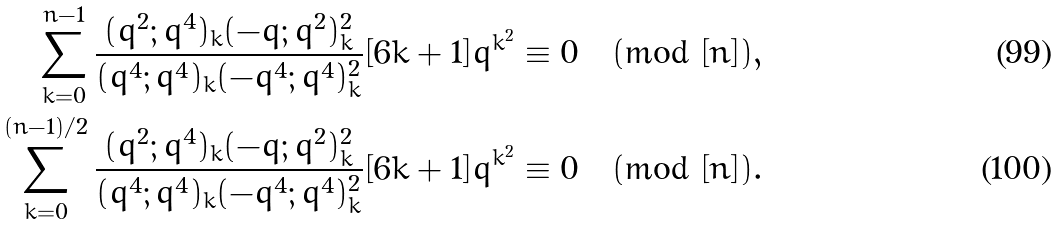<formula> <loc_0><loc_0><loc_500><loc_500>\sum _ { k = 0 } ^ { n - 1 } \frac { ( q ^ { 2 } ; q ^ { 4 } ) _ { k } ( - q ; q ^ { 2 } ) _ { k } ^ { 2 } } { ( q ^ { 4 } ; q ^ { 4 } ) _ { k } ( - q ^ { 4 } ; q ^ { 4 } ) _ { k } ^ { 2 } } [ 6 k + 1 ] q ^ { k ^ { 2 } } & \equiv 0 \pmod { [ n ] } , \\ \sum _ { k = 0 } ^ { ( n - 1 ) / 2 } \frac { ( q ^ { 2 } ; q ^ { 4 } ) _ { k } ( - q ; q ^ { 2 } ) _ { k } ^ { 2 } } { ( q ^ { 4 } ; q ^ { 4 } ) _ { k } ( - q ^ { 4 } ; q ^ { 4 } ) _ { k } ^ { 2 } } [ 6 k + 1 ] q ^ { k ^ { 2 } } & \equiv 0 \pmod { [ n ] } .</formula> 